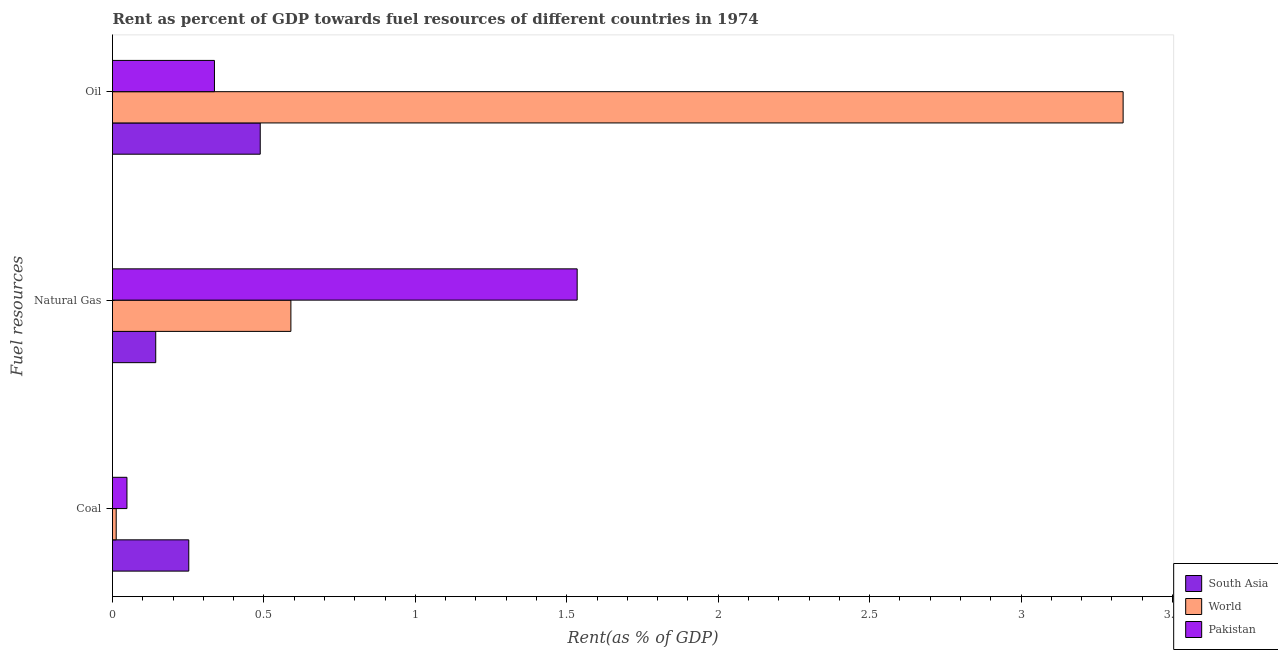How many different coloured bars are there?
Provide a short and direct response. 3. How many bars are there on the 1st tick from the bottom?
Offer a terse response. 3. What is the label of the 1st group of bars from the top?
Your answer should be very brief. Oil. What is the rent towards oil in Pakistan?
Offer a terse response. 0.34. Across all countries, what is the maximum rent towards natural gas?
Keep it short and to the point. 1.53. Across all countries, what is the minimum rent towards natural gas?
Offer a terse response. 0.14. In which country was the rent towards oil maximum?
Offer a terse response. World. What is the total rent towards natural gas in the graph?
Your answer should be compact. 2.27. What is the difference between the rent towards coal in Pakistan and that in World?
Provide a succinct answer. 0.04. What is the difference between the rent towards oil in South Asia and the rent towards coal in Pakistan?
Your answer should be compact. 0.44. What is the average rent towards natural gas per country?
Ensure brevity in your answer.  0.76. What is the difference between the rent towards coal and rent towards oil in World?
Your answer should be compact. -3.32. What is the ratio of the rent towards coal in World to that in Pakistan?
Your answer should be very brief. 0.26. Is the rent towards coal in South Asia less than that in Pakistan?
Keep it short and to the point. No. What is the difference between the highest and the second highest rent towards oil?
Your answer should be very brief. 2.85. What is the difference between the highest and the lowest rent towards oil?
Your response must be concise. 3. In how many countries, is the rent towards natural gas greater than the average rent towards natural gas taken over all countries?
Offer a very short reply. 1. Is the sum of the rent towards natural gas in South Asia and Pakistan greater than the maximum rent towards coal across all countries?
Your response must be concise. Yes. What does the 2nd bar from the top in Oil represents?
Offer a very short reply. World. What does the 1st bar from the bottom in Oil represents?
Offer a very short reply. South Asia. Is it the case that in every country, the sum of the rent towards coal and rent towards natural gas is greater than the rent towards oil?
Offer a very short reply. No. How many countries are there in the graph?
Offer a terse response. 3. What is the title of the graph?
Offer a terse response. Rent as percent of GDP towards fuel resources of different countries in 1974. What is the label or title of the X-axis?
Provide a short and direct response. Rent(as % of GDP). What is the label or title of the Y-axis?
Provide a succinct answer. Fuel resources. What is the Rent(as % of GDP) of South Asia in Coal?
Your answer should be compact. 0.25. What is the Rent(as % of GDP) of World in Coal?
Offer a very short reply. 0.01. What is the Rent(as % of GDP) of Pakistan in Coal?
Ensure brevity in your answer.  0.05. What is the Rent(as % of GDP) in South Asia in Natural Gas?
Keep it short and to the point. 0.14. What is the Rent(as % of GDP) in World in Natural Gas?
Make the answer very short. 0.59. What is the Rent(as % of GDP) of Pakistan in Natural Gas?
Offer a terse response. 1.53. What is the Rent(as % of GDP) of South Asia in Oil?
Your response must be concise. 0.49. What is the Rent(as % of GDP) in World in Oil?
Offer a very short reply. 3.34. What is the Rent(as % of GDP) in Pakistan in Oil?
Keep it short and to the point. 0.34. Across all Fuel resources, what is the maximum Rent(as % of GDP) of South Asia?
Provide a succinct answer. 0.49. Across all Fuel resources, what is the maximum Rent(as % of GDP) of World?
Offer a very short reply. 3.34. Across all Fuel resources, what is the maximum Rent(as % of GDP) in Pakistan?
Your answer should be compact. 1.53. Across all Fuel resources, what is the minimum Rent(as % of GDP) in South Asia?
Your response must be concise. 0.14. Across all Fuel resources, what is the minimum Rent(as % of GDP) of World?
Your answer should be compact. 0.01. Across all Fuel resources, what is the minimum Rent(as % of GDP) of Pakistan?
Offer a terse response. 0.05. What is the total Rent(as % of GDP) of South Asia in the graph?
Your response must be concise. 0.88. What is the total Rent(as % of GDP) in World in the graph?
Provide a succinct answer. 3.94. What is the total Rent(as % of GDP) in Pakistan in the graph?
Give a very brief answer. 1.92. What is the difference between the Rent(as % of GDP) of South Asia in Coal and that in Natural Gas?
Your answer should be very brief. 0.11. What is the difference between the Rent(as % of GDP) of World in Coal and that in Natural Gas?
Offer a terse response. -0.58. What is the difference between the Rent(as % of GDP) in Pakistan in Coal and that in Natural Gas?
Your answer should be compact. -1.49. What is the difference between the Rent(as % of GDP) of South Asia in Coal and that in Oil?
Keep it short and to the point. -0.24. What is the difference between the Rent(as % of GDP) in World in Coal and that in Oil?
Offer a very short reply. -3.32. What is the difference between the Rent(as % of GDP) in Pakistan in Coal and that in Oil?
Ensure brevity in your answer.  -0.29. What is the difference between the Rent(as % of GDP) of South Asia in Natural Gas and that in Oil?
Make the answer very short. -0.35. What is the difference between the Rent(as % of GDP) of World in Natural Gas and that in Oil?
Give a very brief answer. -2.75. What is the difference between the Rent(as % of GDP) in Pakistan in Natural Gas and that in Oil?
Your answer should be very brief. 1.2. What is the difference between the Rent(as % of GDP) in South Asia in Coal and the Rent(as % of GDP) in World in Natural Gas?
Offer a terse response. -0.34. What is the difference between the Rent(as % of GDP) in South Asia in Coal and the Rent(as % of GDP) in Pakistan in Natural Gas?
Provide a succinct answer. -1.28. What is the difference between the Rent(as % of GDP) of World in Coal and the Rent(as % of GDP) of Pakistan in Natural Gas?
Make the answer very short. -1.52. What is the difference between the Rent(as % of GDP) of South Asia in Coal and the Rent(as % of GDP) of World in Oil?
Your answer should be very brief. -3.09. What is the difference between the Rent(as % of GDP) in South Asia in Coal and the Rent(as % of GDP) in Pakistan in Oil?
Keep it short and to the point. -0.08. What is the difference between the Rent(as % of GDP) in World in Coal and the Rent(as % of GDP) in Pakistan in Oil?
Give a very brief answer. -0.32. What is the difference between the Rent(as % of GDP) in South Asia in Natural Gas and the Rent(as % of GDP) in World in Oil?
Offer a terse response. -3.19. What is the difference between the Rent(as % of GDP) in South Asia in Natural Gas and the Rent(as % of GDP) in Pakistan in Oil?
Provide a succinct answer. -0.19. What is the difference between the Rent(as % of GDP) of World in Natural Gas and the Rent(as % of GDP) of Pakistan in Oil?
Make the answer very short. 0.25. What is the average Rent(as % of GDP) of South Asia per Fuel resources?
Offer a terse response. 0.29. What is the average Rent(as % of GDP) of World per Fuel resources?
Give a very brief answer. 1.31. What is the average Rent(as % of GDP) in Pakistan per Fuel resources?
Your response must be concise. 0.64. What is the difference between the Rent(as % of GDP) in South Asia and Rent(as % of GDP) in World in Coal?
Your answer should be very brief. 0.24. What is the difference between the Rent(as % of GDP) of South Asia and Rent(as % of GDP) of Pakistan in Coal?
Provide a short and direct response. 0.2. What is the difference between the Rent(as % of GDP) of World and Rent(as % of GDP) of Pakistan in Coal?
Your answer should be very brief. -0.04. What is the difference between the Rent(as % of GDP) in South Asia and Rent(as % of GDP) in World in Natural Gas?
Provide a short and direct response. -0.45. What is the difference between the Rent(as % of GDP) in South Asia and Rent(as % of GDP) in Pakistan in Natural Gas?
Offer a terse response. -1.39. What is the difference between the Rent(as % of GDP) of World and Rent(as % of GDP) of Pakistan in Natural Gas?
Your answer should be very brief. -0.95. What is the difference between the Rent(as % of GDP) of South Asia and Rent(as % of GDP) of World in Oil?
Your response must be concise. -2.85. What is the difference between the Rent(as % of GDP) of South Asia and Rent(as % of GDP) of Pakistan in Oil?
Keep it short and to the point. 0.15. What is the difference between the Rent(as % of GDP) of World and Rent(as % of GDP) of Pakistan in Oil?
Offer a terse response. 3. What is the ratio of the Rent(as % of GDP) in South Asia in Coal to that in Natural Gas?
Offer a very short reply. 1.76. What is the ratio of the Rent(as % of GDP) of World in Coal to that in Natural Gas?
Your answer should be very brief. 0.02. What is the ratio of the Rent(as % of GDP) of Pakistan in Coal to that in Natural Gas?
Offer a very short reply. 0.03. What is the ratio of the Rent(as % of GDP) of South Asia in Coal to that in Oil?
Provide a short and direct response. 0.52. What is the ratio of the Rent(as % of GDP) of World in Coal to that in Oil?
Your answer should be compact. 0. What is the ratio of the Rent(as % of GDP) of Pakistan in Coal to that in Oil?
Make the answer very short. 0.14. What is the ratio of the Rent(as % of GDP) in South Asia in Natural Gas to that in Oil?
Your answer should be very brief. 0.29. What is the ratio of the Rent(as % of GDP) of World in Natural Gas to that in Oil?
Provide a short and direct response. 0.18. What is the ratio of the Rent(as % of GDP) of Pakistan in Natural Gas to that in Oil?
Provide a short and direct response. 4.56. What is the difference between the highest and the second highest Rent(as % of GDP) in South Asia?
Your answer should be very brief. 0.24. What is the difference between the highest and the second highest Rent(as % of GDP) in World?
Offer a very short reply. 2.75. What is the difference between the highest and the second highest Rent(as % of GDP) in Pakistan?
Your answer should be very brief. 1.2. What is the difference between the highest and the lowest Rent(as % of GDP) in South Asia?
Offer a terse response. 0.35. What is the difference between the highest and the lowest Rent(as % of GDP) of World?
Keep it short and to the point. 3.32. What is the difference between the highest and the lowest Rent(as % of GDP) in Pakistan?
Your answer should be compact. 1.49. 